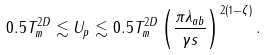Convert formula to latex. <formula><loc_0><loc_0><loc_500><loc_500>0 . 5 T _ { m } ^ { 2 D } \lesssim U _ { p } \lesssim 0 . 5 T _ { m } ^ { 2 D } \left ( \frac { \pi \lambda _ { a b } } { \gamma s } \right ) ^ { 2 ( 1 - \zeta ) } .</formula> 